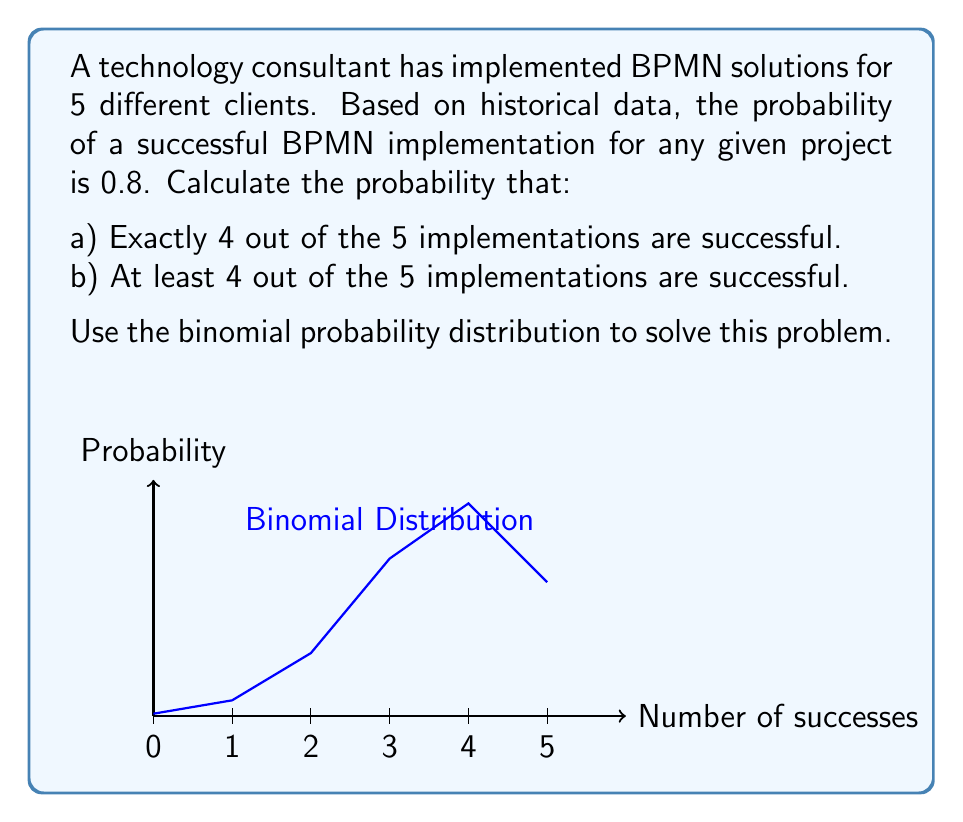What is the answer to this math problem? Let's approach this step-by-step using the binomial probability distribution:

1) The binomial probability formula is:

   $$P(X = k) = \binom{n}{k} p^k (1-p)^{n-k}$$

   Where:
   $n$ = number of trials
   $k$ = number of successes
   $p$ = probability of success on each trial

2) For this problem:
   $n = 5$ (total implementations)
   $p = 0.8$ (probability of success for each implementation)

3) For part a), we need to calculate $P(X = 4)$:

   $$P(X = 4) = \binom{5}{4} (0.8)^4 (1-0.8)^{5-4}$$

   $$= 5 \cdot (0.8)^4 \cdot (0.2)^1$$
   
   $$= 5 \cdot 0.4096 \cdot 0.2$$
   
   $$= 0.4096$$

4) For part b), we need to calculate $P(X \geq 4)$:

   This is the sum of probabilities of 4 successes and 5 successes:
   
   $$P(X \geq 4) = P(X = 4) + P(X = 5)$$

   We already calculated $P(X = 4)$. Now let's calculate $P(X = 5)$:

   $$P(X = 5) = \binom{5}{5} (0.8)^5 (1-0.8)^{5-5}$$

   $$= 1 \cdot (0.8)^5 \cdot (0.2)^0$$
   
   $$= 0.32768$$

   Therefore,

   $$P(X \geq 4) = 0.4096 + 0.32768 = 0.73728$$
Answer: a) 0.4096
b) 0.73728 